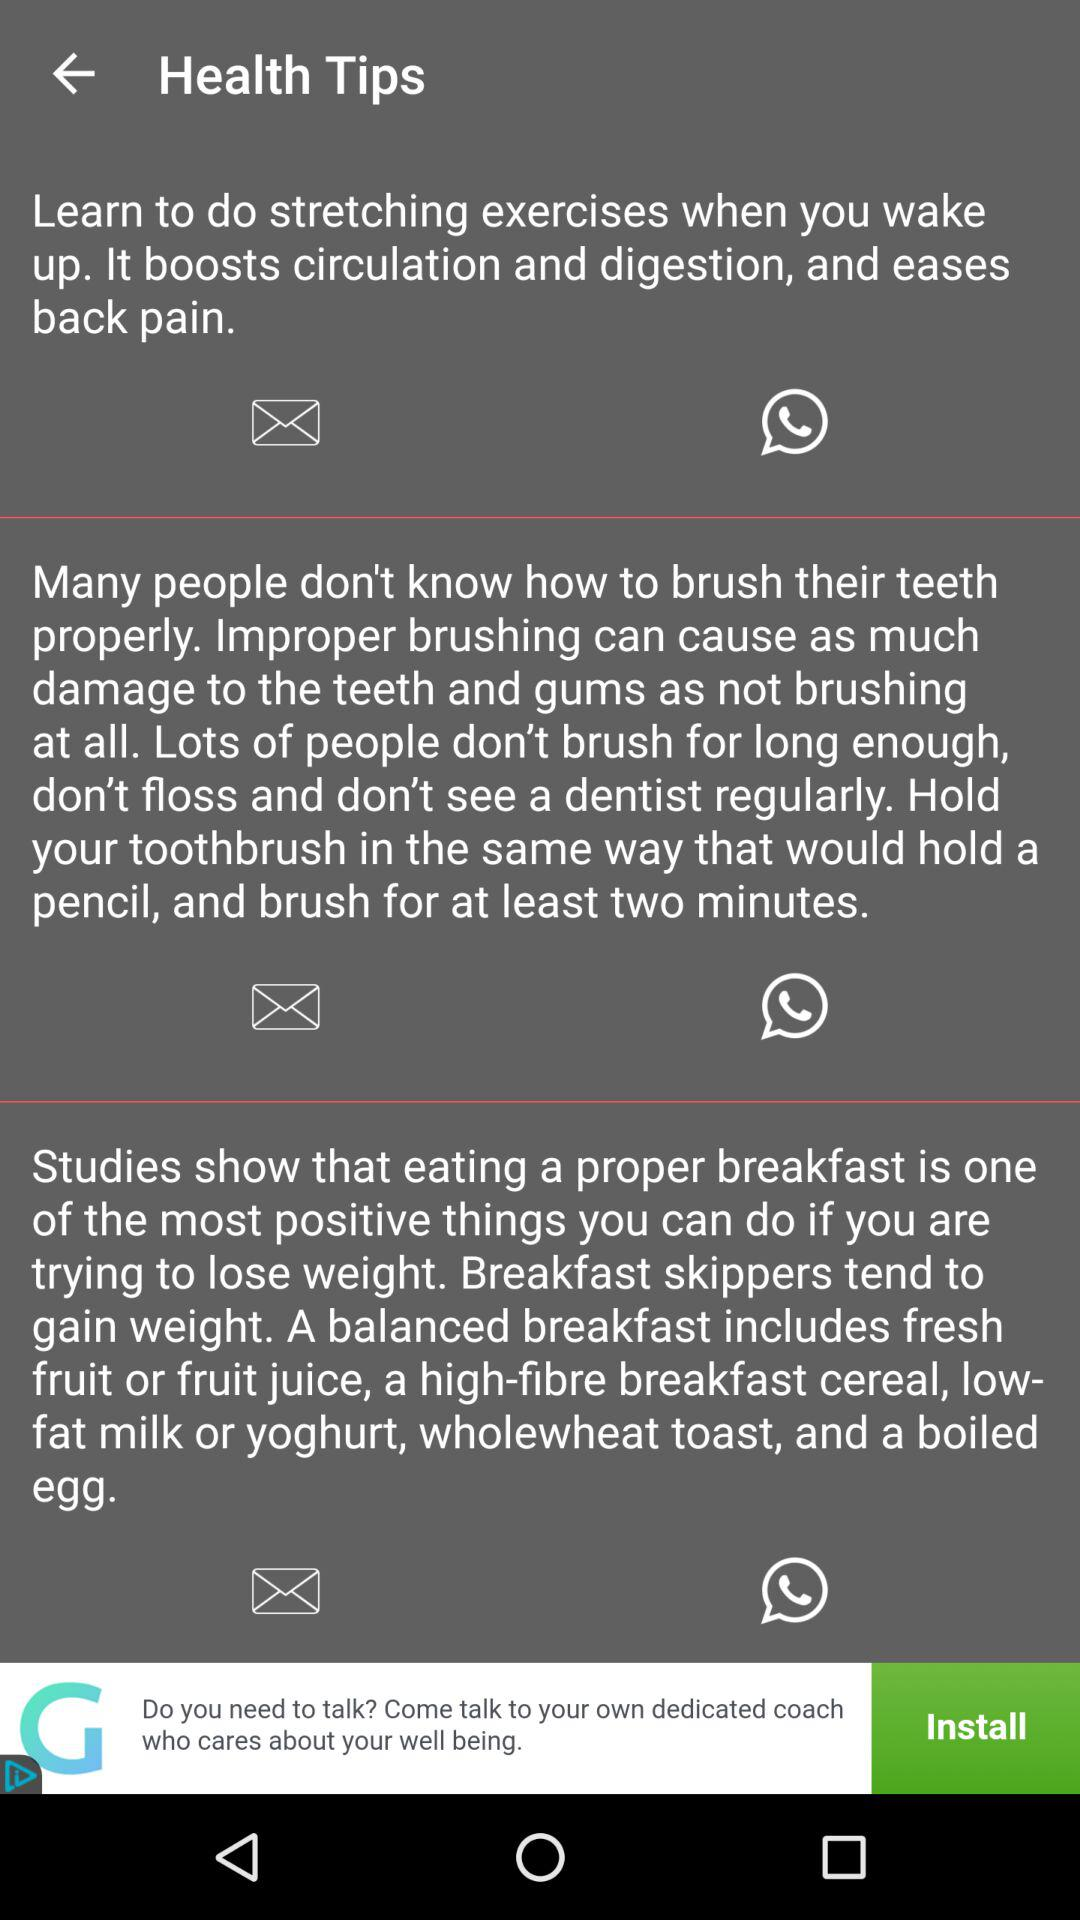What are the different health tips given? The different health tips are: "Learn to do stretching exercises when you wake up. It boosts circulation and digestion, and eases back pain" and "Many people don't know how to brush their teeth properly. Improper brushing can cause as much damage to the teeth and gums as not brushing at all. Lots of people don't brush for long enough, don't floss and don't see a dentist regularly. Hold your toothbrush in the same way that would hold a pencil, and brush for at least two minutes", "Studies show that eating a proper breakfast is one of the most positive things you can do if you are trying to lose weight. Breakfast skippers tend to gain weight. A balanced breakfast includes fresh fruit or fruit juice, a high-fibre breakfast cereal, low fat milk or yoghurt, wholewheat toast, and a boiled egg". 